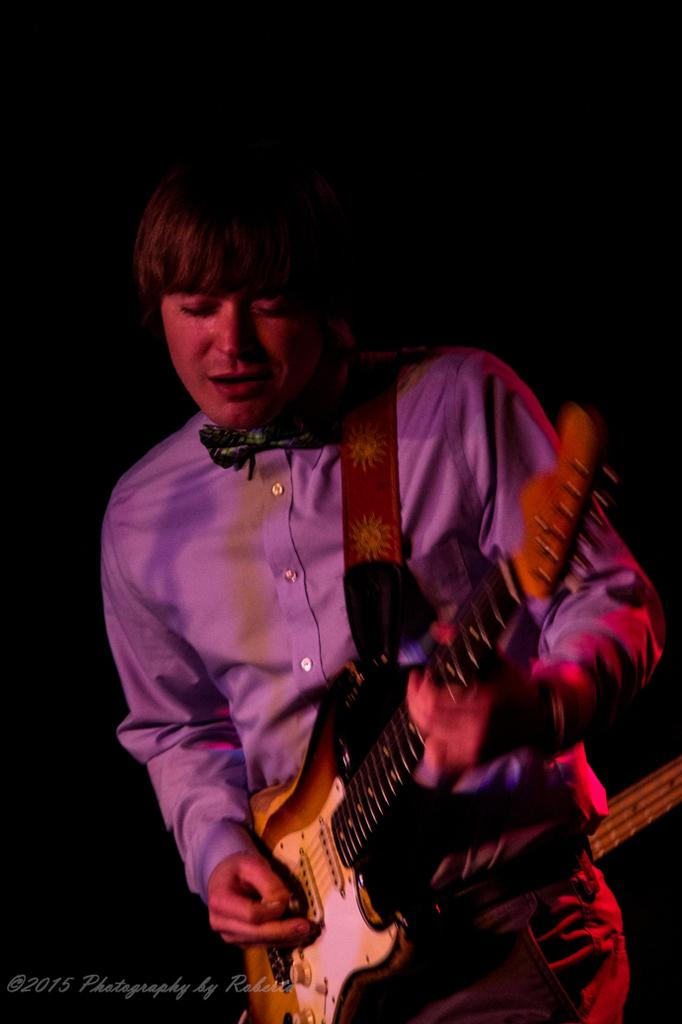What is the main subject of the image? There is a person in the image. What is the person wearing? The person is wearing a violet shirt. What activity is the person engaged in? The person is playing the guitar. What is the color of the background in the image? The background of the image is black. Can you hear the person whistling in the image? There is no sound in the image, so it is not possible to hear the person whistling. How many pizzas are present in the image? There are no pizzas present in the image. What type of disease can be seen affecting the person in the image? There is no indication of any disease affecting the person in the image. 